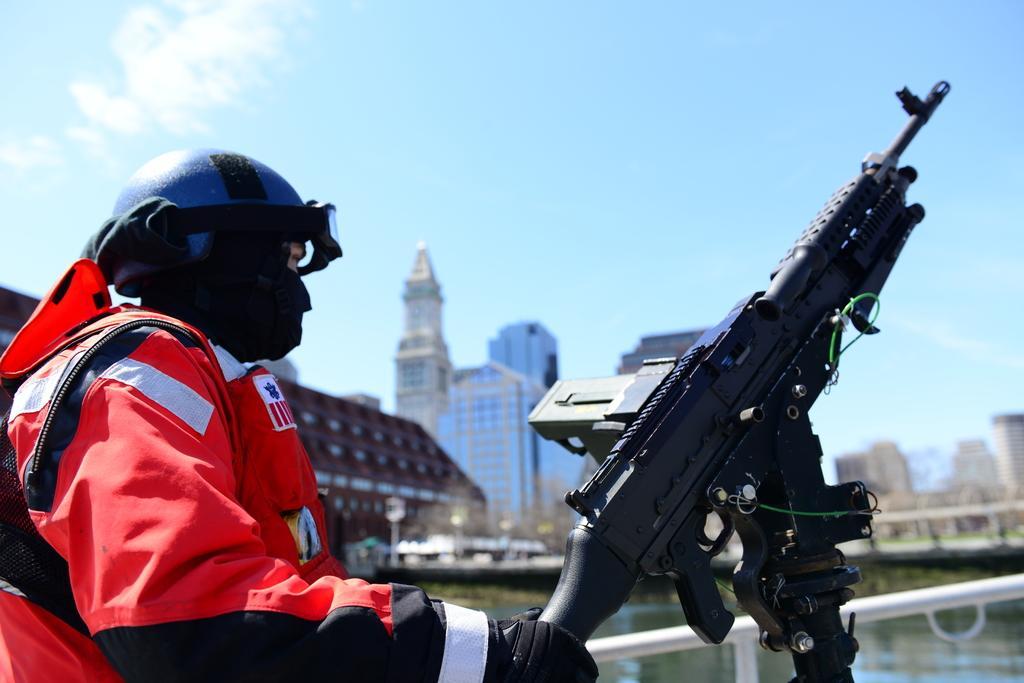In one or two sentences, can you explain what this image depicts? In this picture there is a machine gun on the right side of the image and there is a man who is standing on the left side of the image and there are buildings, a bridge, and water in the background area of the image, there is a boundary at the bottom side of the image. 